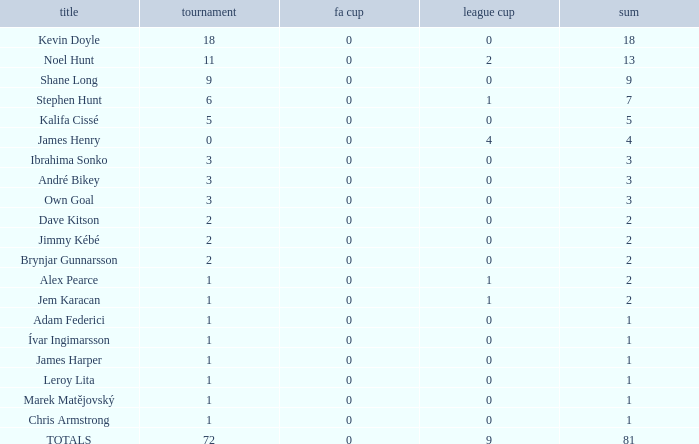Write the full table. {'header': ['title', 'tournament', 'fa cup', 'league cup', 'sum'], 'rows': [['Kevin Doyle', '18', '0', '0', '18'], ['Noel Hunt', '11', '0', '2', '13'], ['Shane Long', '9', '0', '0', '9'], ['Stephen Hunt', '6', '0', '1', '7'], ['Kalifa Cissé', '5', '0', '0', '5'], ['James Henry', '0', '0', '4', '4'], ['Ibrahima Sonko', '3', '0', '0', '3'], ['André Bikey', '3', '0', '0', '3'], ['Own Goal', '3', '0', '0', '3'], ['Dave Kitson', '2', '0', '0', '2'], ['Jimmy Kébé', '2', '0', '0', '2'], ['Brynjar Gunnarsson', '2', '0', '0', '2'], ['Alex Pearce', '1', '0', '1', '2'], ['Jem Karacan', '1', '0', '1', '2'], ['Adam Federici', '1', '0', '0', '1'], ['Ívar Ingimarsson', '1', '0', '0', '1'], ['James Harper', '1', '0', '0', '1'], ['Leroy Lita', '1', '0', '0', '1'], ['Marek Matějovský', '1', '0', '0', '1'], ['Chris Armstrong', '1', '0', '0', '1'], ['TOTALS', '72', '0', '9', '81']]} What is the cumulative championships where the league cup is below 0? None. 